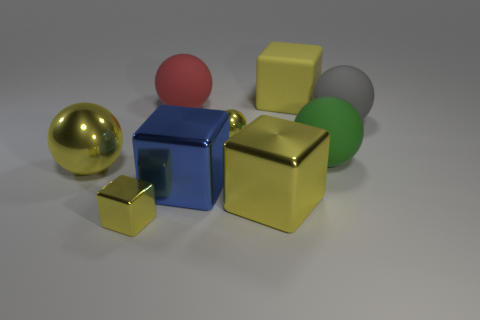Which of these items would be the heaviest and lightest in reality, based on their material? If we were to consider common materials these objects might represent, the metallic gold sphere would likely be the heaviest, assuming it's made of a dense metal. Conversely, the red sphere and green cylinder, if made of a lightweight plastic, would be the lightest among the objects.  Considering their dimensions in the image, could you guess the relative sizes of these objects in comparison to each other? Observing their dimensions, the yellow cubes come in two different sizes, with one being much smaller than the other. The red sphere and the green cylinder appear similar in size, smaller than the larger yellow cube but larger than the smaller cube. The golden sphere and the blue cube look to be the largest objects in the scene. 